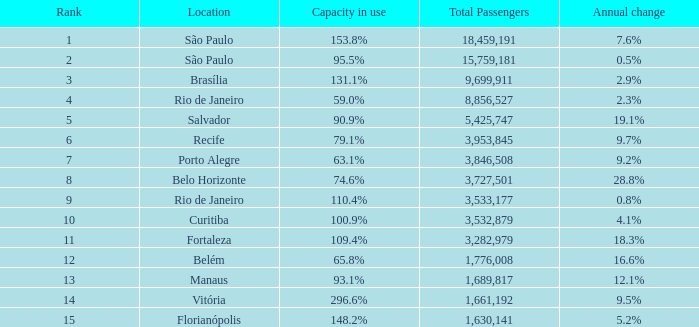What is the total number of Total Passengers when the annual change is 28.8% and the rank is less than 8? 0.0. 